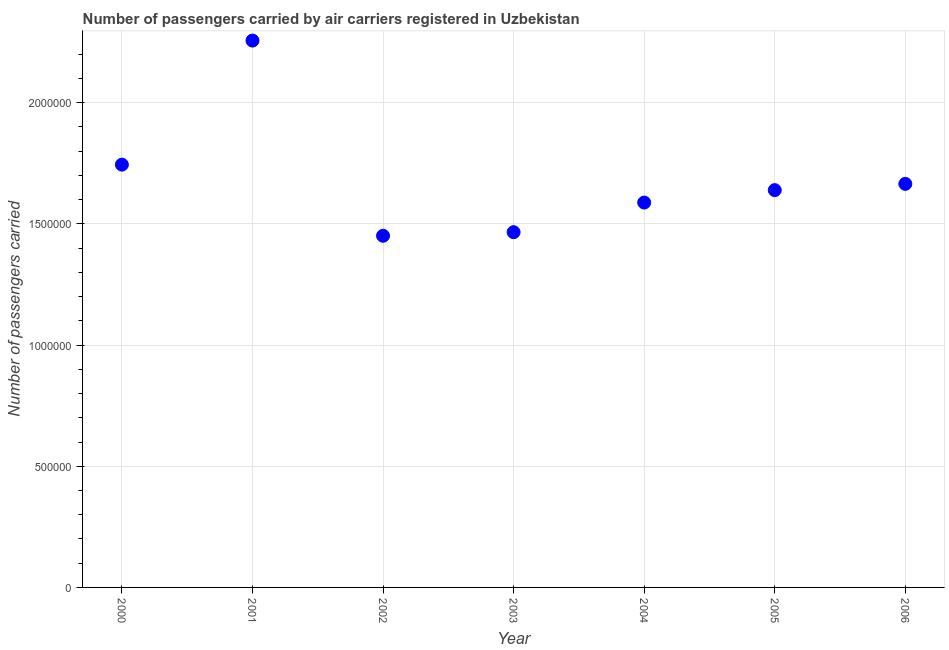What is the number of passengers carried in 2003?
Offer a terse response. 1.47e+06. Across all years, what is the maximum number of passengers carried?
Give a very brief answer. 2.26e+06. Across all years, what is the minimum number of passengers carried?
Provide a succinct answer. 1.45e+06. In which year was the number of passengers carried maximum?
Offer a terse response. 2001. What is the sum of the number of passengers carried?
Provide a short and direct response. 1.18e+07. What is the difference between the number of passengers carried in 2002 and 2003?
Offer a terse response. -1.48e+04. What is the average number of passengers carried per year?
Offer a terse response. 1.69e+06. What is the median number of passengers carried?
Provide a succinct answer. 1.64e+06. In how many years, is the number of passengers carried greater than 100000 ?
Your answer should be very brief. 7. Do a majority of the years between 2001 and 2006 (inclusive) have number of passengers carried greater than 1600000 ?
Provide a short and direct response. No. What is the ratio of the number of passengers carried in 2001 to that in 2003?
Keep it short and to the point. 1.54. What is the difference between the highest and the second highest number of passengers carried?
Your response must be concise. 5.12e+05. Is the sum of the number of passengers carried in 2002 and 2005 greater than the maximum number of passengers carried across all years?
Your answer should be very brief. Yes. What is the difference between the highest and the lowest number of passengers carried?
Your answer should be compact. 8.05e+05. In how many years, is the number of passengers carried greater than the average number of passengers carried taken over all years?
Keep it short and to the point. 2. How many dotlines are there?
Your answer should be compact. 1. How many years are there in the graph?
Your answer should be compact. 7. Are the values on the major ticks of Y-axis written in scientific E-notation?
Your response must be concise. No. Does the graph contain grids?
Provide a short and direct response. Yes. What is the title of the graph?
Offer a terse response. Number of passengers carried by air carriers registered in Uzbekistan. What is the label or title of the X-axis?
Give a very brief answer. Year. What is the label or title of the Y-axis?
Make the answer very short. Number of passengers carried. What is the Number of passengers carried in 2000?
Keep it short and to the point. 1.74e+06. What is the Number of passengers carried in 2001?
Your answer should be very brief. 2.26e+06. What is the Number of passengers carried in 2002?
Provide a short and direct response. 1.45e+06. What is the Number of passengers carried in 2003?
Ensure brevity in your answer.  1.47e+06. What is the Number of passengers carried in 2004?
Ensure brevity in your answer.  1.59e+06. What is the Number of passengers carried in 2005?
Your answer should be very brief. 1.64e+06. What is the Number of passengers carried in 2006?
Offer a terse response. 1.67e+06. What is the difference between the Number of passengers carried in 2000 and 2001?
Ensure brevity in your answer.  -5.12e+05. What is the difference between the Number of passengers carried in 2000 and 2002?
Keep it short and to the point. 2.94e+05. What is the difference between the Number of passengers carried in 2000 and 2003?
Your answer should be compact. 2.79e+05. What is the difference between the Number of passengers carried in 2000 and 2004?
Provide a succinct answer. 1.56e+05. What is the difference between the Number of passengers carried in 2000 and 2005?
Provide a short and direct response. 1.05e+05. What is the difference between the Number of passengers carried in 2000 and 2006?
Make the answer very short. 7.93e+04. What is the difference between the Number of passengers carried in 2001 and 2002?
Your answer should be very brief. 8.05e+05. What is the difference between the Number of passengers carried in 2001 and 2003?
Ensure brevity in your answer.  7.91e+05. What is the difference between the Number of passengers carried in 2001 and 2004?
Make the answer very short. 6.68e+05. What is the difference between the Number of passengers carried in 2001 and 2005?
Your answer should be very brief. 6.17e+05. What is the difference between the Number of passengers carried in 2001 and 2006?
Ensure brevity in your answer.  5.91e+05. What is the difference between the Number of passengers carried in 2002 and 2003?
Offer a very short reply. -1.48e+04. What is the difference between the Number of passengers carried in 2002 and 2004?
Offer a very short reply. -1.37e+05. What is the difference between the Number of passengers carried in 2002 and 2005?
Offer a very short reply. -1.88e+05. What is the difference between the Number of passengers carried in 2002 and 2006?
Ensure brevity in your answer.  -2.14e+05. What is the difference between the Number of passengers carried in 2003 and 2004?
Your answer should be compact. -1.22e+05. What is the difference between the Number of passengers carried in 2003 and 2005?
Give a very brief answer. -1.73e+05. What is the difference between the Number of passengers carried in 2003 and 2006?
Give a very brief answer. -1.99e+05. What is the difference between the Number of passengers carried in 2004 and 2005?
Provide a succinct answer. -5.12e+04. What is the difference between the Number of passengers carried in 2004 and 2006?
Provide a succinct answer. -7.71e+04. What is the difference between the Number of passengers carried in 2005 and 2006?
Provide a short and direct response. -2.59e+04. What is the ratio of the Number of passengers carried in 2000 to that in 2001?
Keep it short and to the point. 0.77. What is the ratio of the Number of passengers carried in 2000 to that in 2002?
Your answer should be very brief. 1.2. What is the ratio of the Number of passengers carried in 2000 to that in 2003?
Ensure brevity in your answer.  1.19. What is the ratio of the Number of passengers carried in 2000 to that in 2004?
Provide a short and direct response. 1.1. What is the ratio of the Number of passengers carried in 2000 to that in 2005?
Provide a short and direct response. 1.06. What is the ratio of the Number of passengers carried in 2000 to that in 2006?
Provide a succinct answer. 1.05. What is the ratio of the Number of passengers carried in 2001 to that in 2002?
Your response must be concise. 1.55. What is the ratio of the Number of passengers carried in 2001 to that in 2003?
Keep it short and to the point. 1.54. What is the ratio of the Number of passengers carried in 2001 to that in 2004?
Offer a terse response. 1.42. What is the ratio of the Number of passengers carried in 2001 to that in 2005?
Your answer should be compact. 1.38. What is the ratio of the Number of passengers carried in 2001 to that in 2006?
Keep it short and to the point. 1.35. What is the ratio of the Number of passengers carried in 2002 to that in 2004?
Your answer should be very brief. 0.91. What is the ratio of the Number of passengers carried in 2002 to that in 2005?
Offer a very short reply. 0.89. What is the ratio of the Number of passengers carried in 2002 to that in 2006?
Offer a very short reply. 0.87. What is the ratio of the Number of passengers carried in 2003 to that in 2004?
Provide a succinct answer. 0.92. What is the ratio of the Number of passengers carried in 2003 to that in 2005?
Your answer should be very brief. 0.89. What is the ratio of the Number of passengers carried in 2003 to that in 2006?
Provide a short and direct response. 0.88. What is the ratio of the Number of passengers carried in 2004 to that in 2006?
Offer a terse response. 0.95. What is the ratio of the Number of passengers carried in 2005 to that in 2006?
Ensure brevity in your answer.  0.98. 